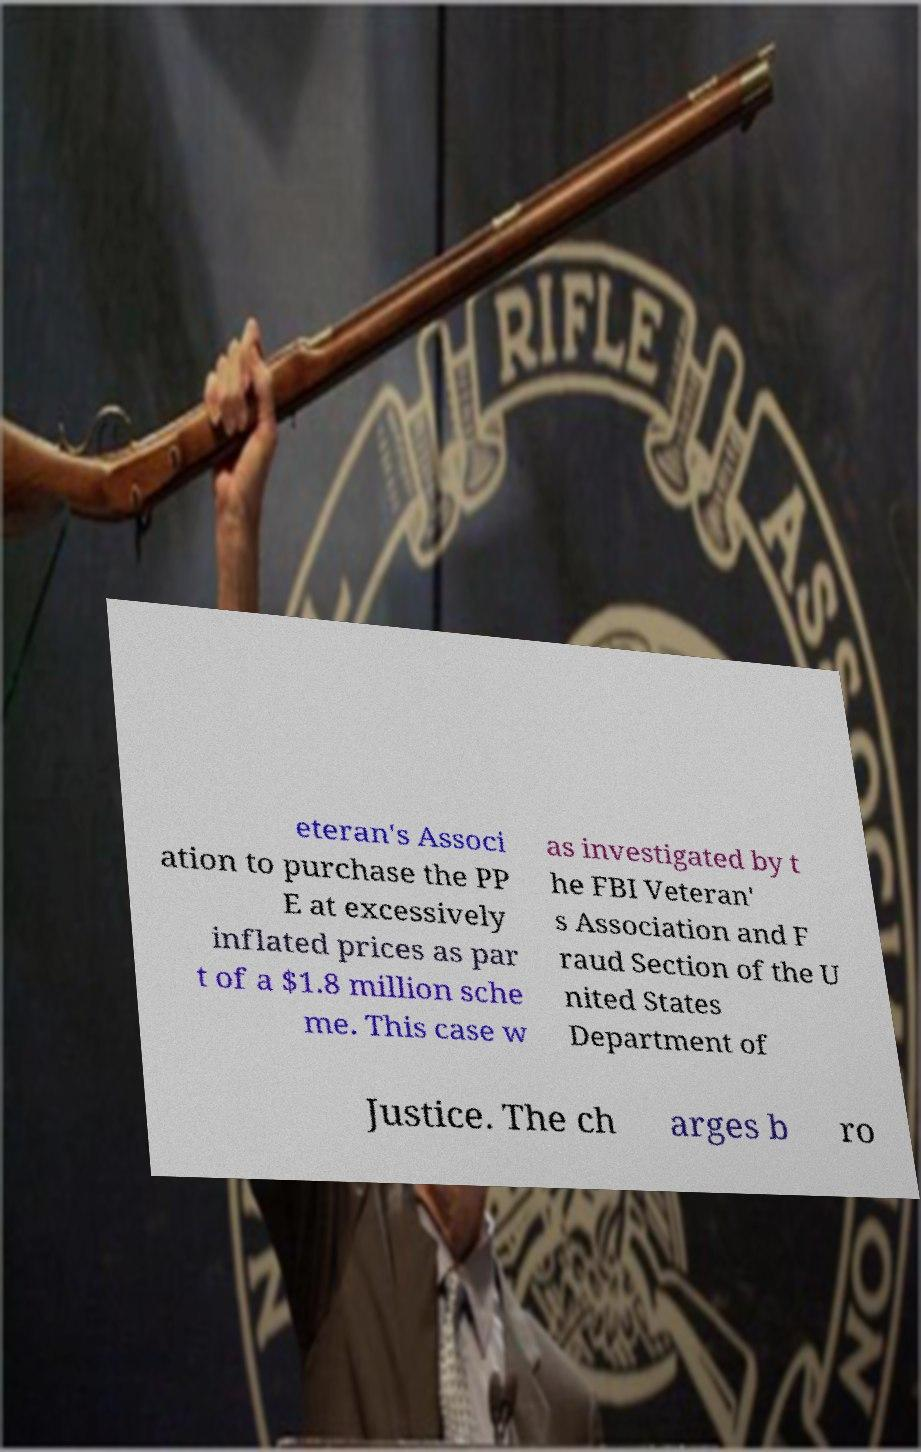I need the written content from this picture converted into text. Can you do that? eteran's Associ ation to purchase the PP E at excessively inflated prices as par t of a $1.8 million sche me. This case w as investigated by t he FBI Veteran' s Association and F raud Section of the U nited States Department of Justice. The ch arges b ro 